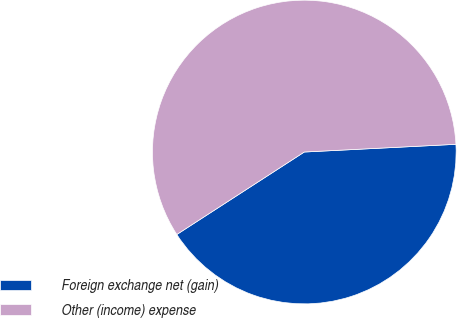Convert chart. <chart><loc_0><loc_0><loc_500><loc_500><pie_chart><fcel>Foreign exchange net (gain)<fcel>Other (income) expense<nl><fcel>41.67%<fcel>58.33%<nl></chart> 